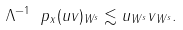Convert formula to latex. <formula><loc_0><loc_0><loc_500><loc_500>\| \Lambda ^ { - 1 } \ p _ { x } ( u v ) \| _ { W ^ { s } } \lesssim \| u \| _ { W ^ { s } } \| v \| _ { W ^ { s } } .</formula> 